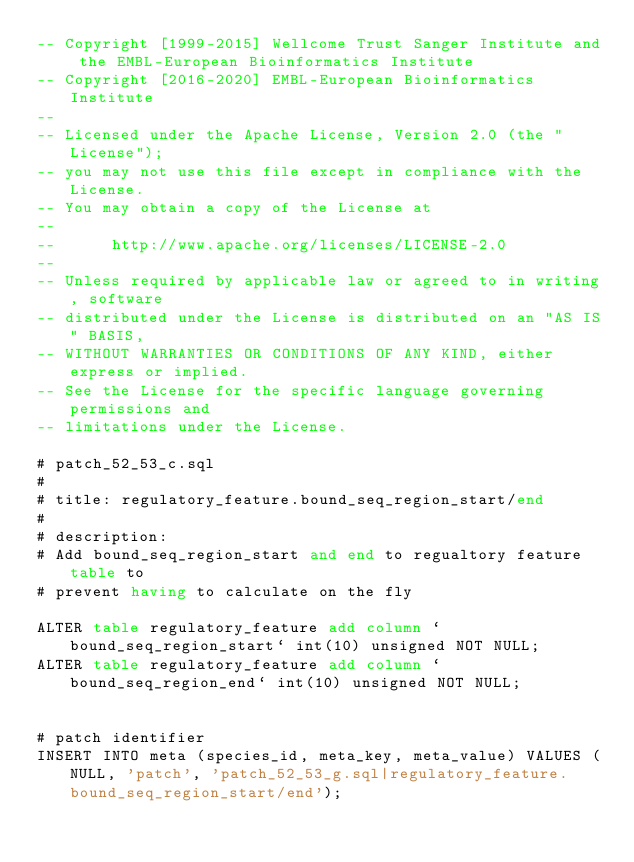Convert code to text. <code><loc_0><loc_0><loc_500><loc_500><_SQL_>-- Copyright [1999-2015] Wellcome Trust Sanger Institute and the EMBL-European Bioinformatics Institute
-- Copyright [2016-2020] EMBL-European Bioinformatics Institute
-- 
-- Licensed under the Apache License, Version 2.0 (the "License");
-- you may not use this file except in compliance with the License.
-- You may obtain a copy of the License at
-- 
--      http://www.apache.org/licenses/LICENSE-2.0
-- 
-- Unless required by applicable law or agreed to in writing, software
-- distributed under the License is distributed on an "AS IS" BASIS,
-- WITHOUT WARRANTIES OR CONDITIONS OF ANY KIND, either express or implied.
-- See the License for the specific language governing permissions and
-- limitations under the License.

# patch_52_53_c.sql
#
# title: regulatory_feature.bound_seq_region_start/end
#
# description:
# Add bound_seq_region_start and end to regualtory feature table to 
# prevent having to calculate on the fly

ALTER table regulatory_feature add column `bound_seq_region_start` int(10) unsigned NOT NULL;
ALTER table regulatory_feature add column `bound_seq_region_end` int(10) unsigned NOT NULL;


# patch identifier
INSERT INTO meta (species_id, meta_key, meta_value) VALUES (NULL, 'patch', 'patch_52_53_g.sql|regulatory_feature.bound_seq_region_start/end');


</code> 